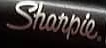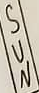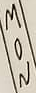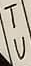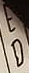What words can you see in these images in sequence, separated by a semicolon? Sharpie.; SUN; MON; TU; ED 